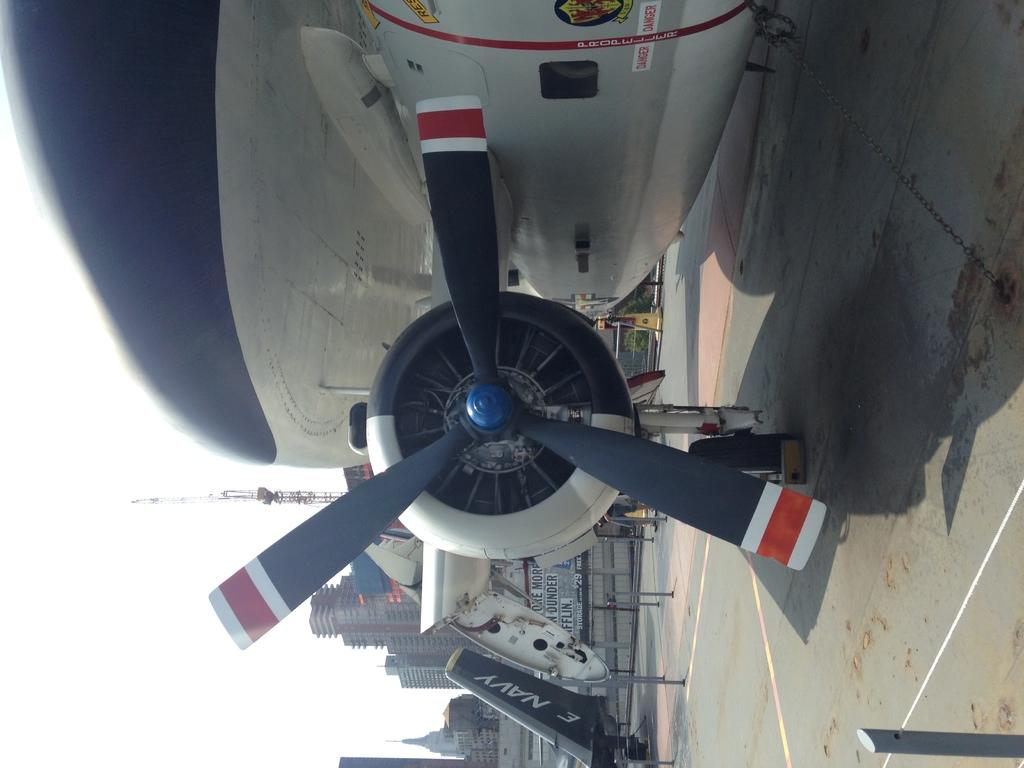<image>
Share a concise interpretation of the image provided. A couple of airplanes on the tarmac, one saying Navy on the tail. 